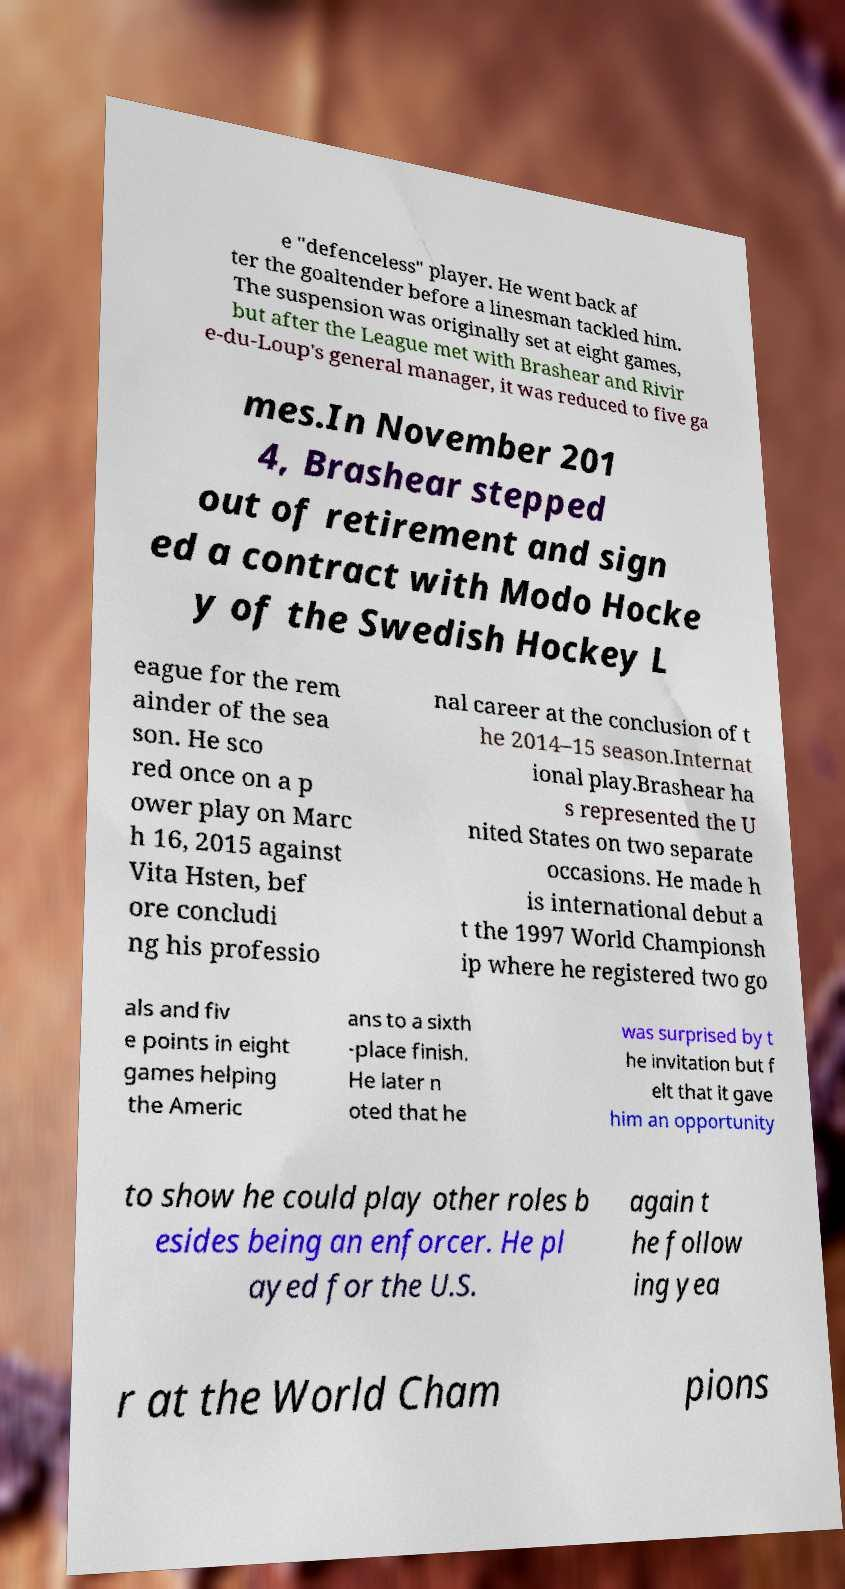Can you read and provide the text displayed in the image?This photo seems to have some interesting text. Can you extract and type it out for me? e "defenceless" player. He went back af ter the goaltender before a linesman tackled him. The suspension was originally set at eight games, but after the League met with Brashear and Rivir e-du-Loup's general manager, it was reduced to five ga mes.In November 201 4, Brashear stepped out of retirement and sign ed a contract with Modo Hocke y of the Swedish Hockey L eague for the rem ainder of the sea son. He sco red once on a p ower play on Marc h 16, 2015 against Vita Hsten, bef ore concludi ng his professio nal career at the conclusion of t he 2014–15 season.Internat ional play.Brashear ha s represented the U nited States on two separate occasions. He made h is international debut a t the 1997 World Championsh ip where he registered two go als and fiv e points in eight games helping the Americ ans to a sixth -place finish. He later n oted that he was surprised by t he invitation but f elt that it gave him an opportunity to show he could play other roles b esides being an enforcer. He pl ayed for the U.S. again t he follow ing yea r at the World Cham pions 